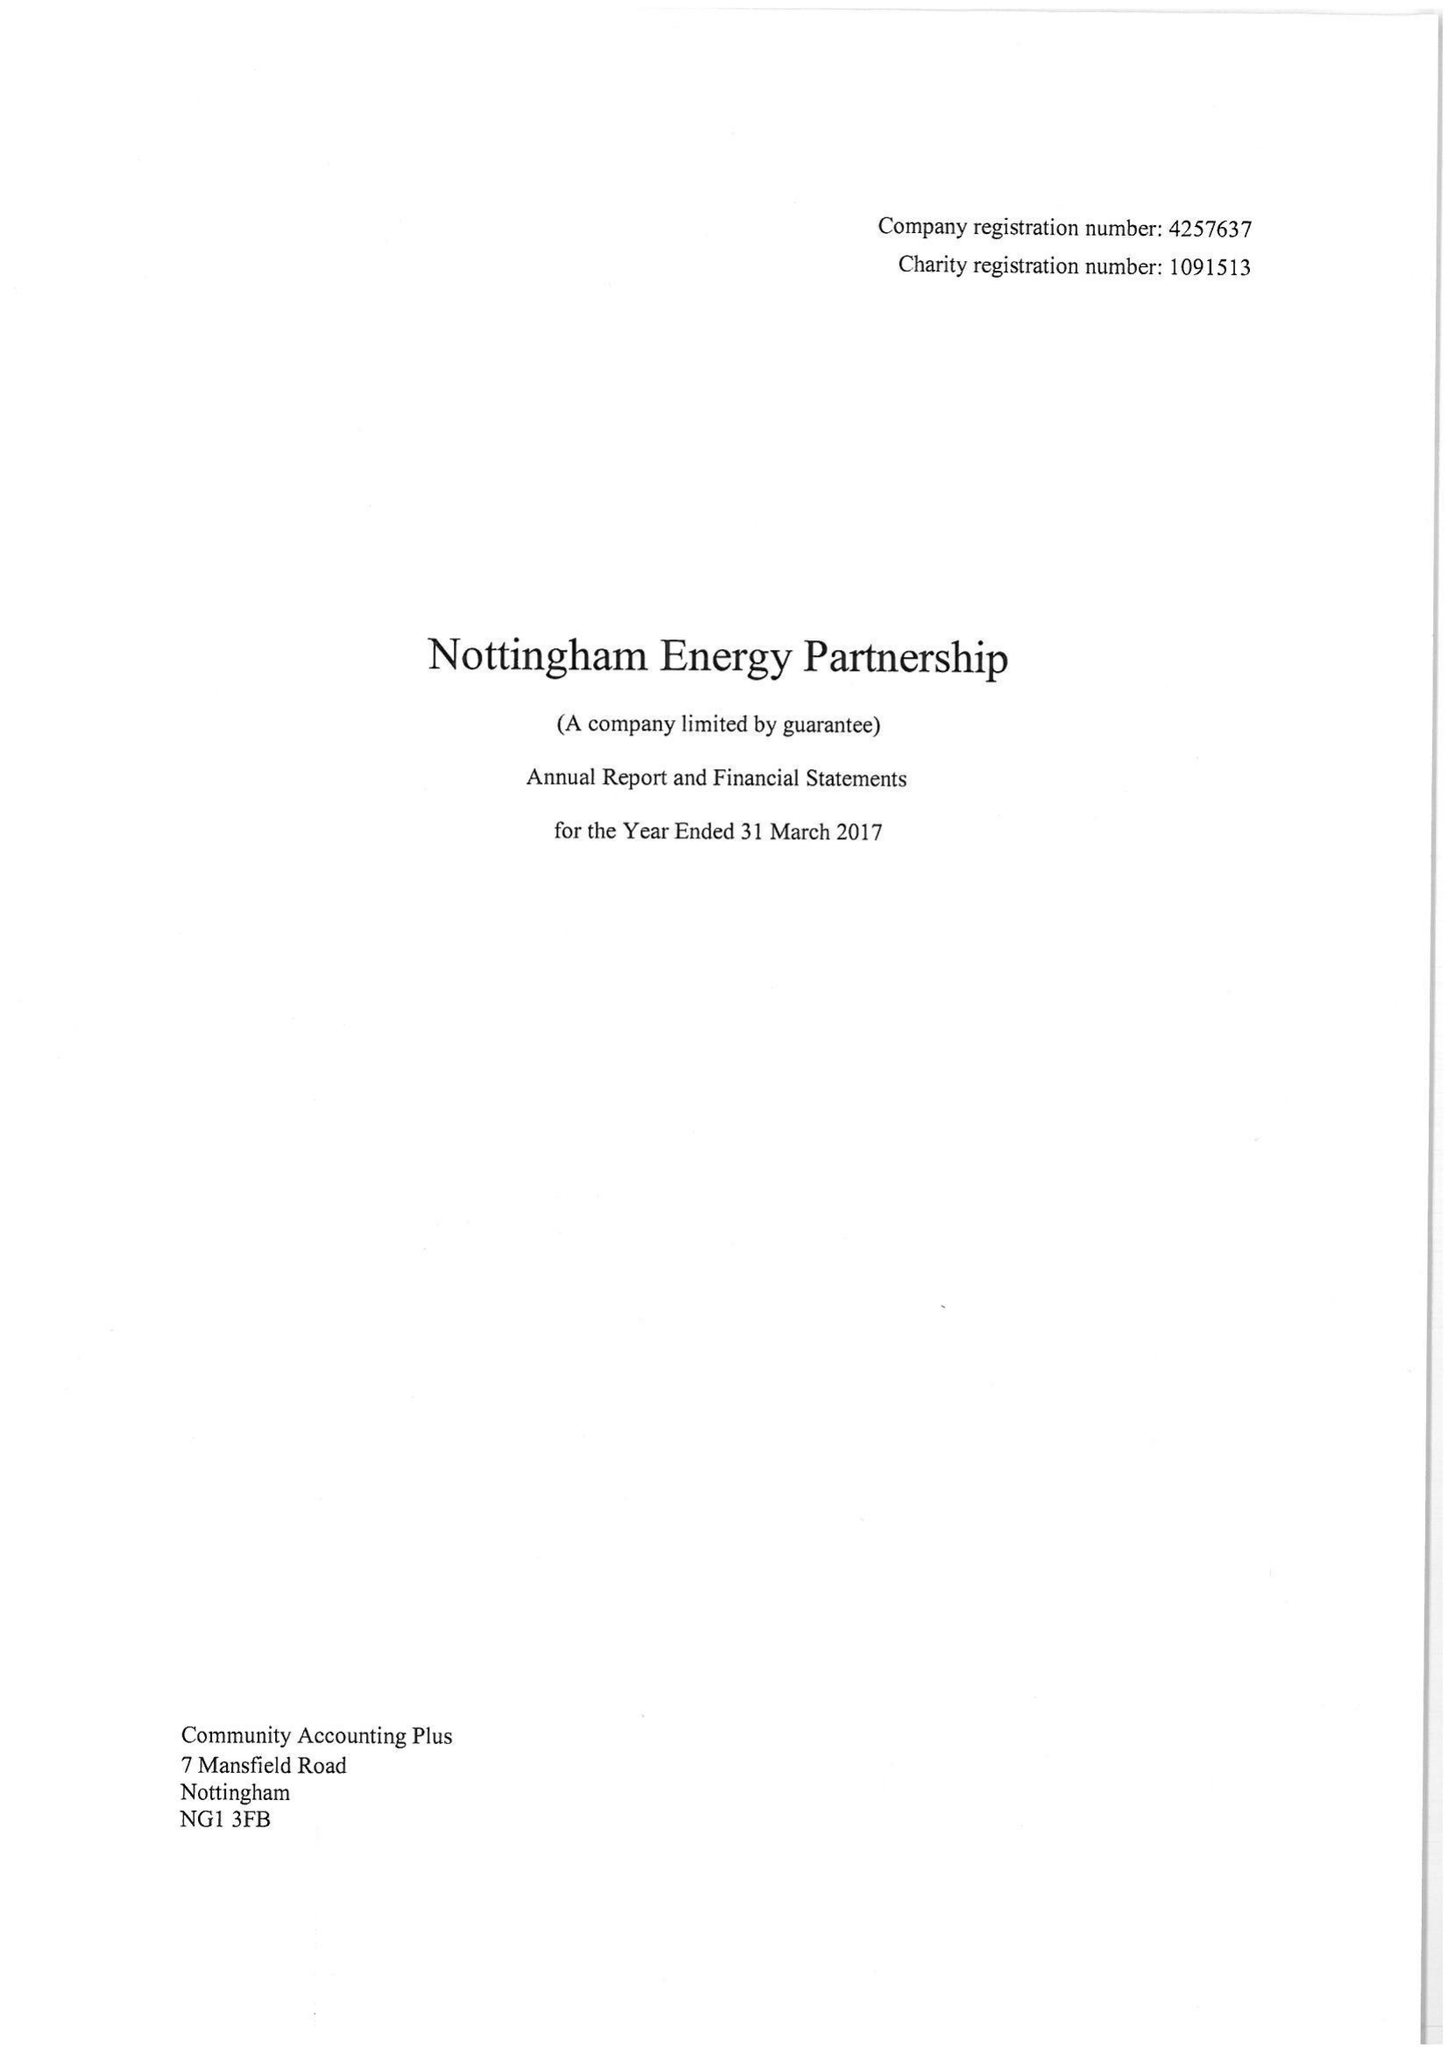What is the value for the address__post_town?
Answer the question using a single word or phrase. NOTTINGHAM 